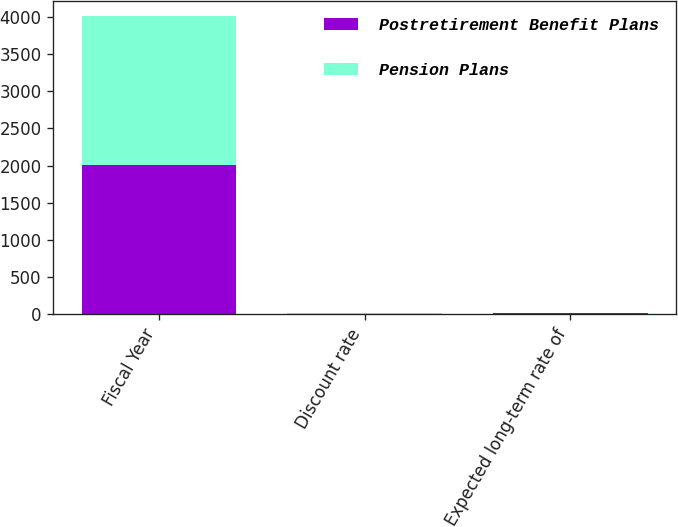Convert chart. <chart><loc_0><loc_0><loc_500><loc_500><stacked_bar_chart><ecel><fcel>Fiscal Year<fcel>Discount rate<fcel>Expected long-term rate of<nl><fcel>Postretirement Benefit Plans<fcel>2005<fcel>6.65<fcel>9.6<nl><fcel>Pension Plans<fcel>2005<fcel>6.65<fcel>9.6<nl></chart> 